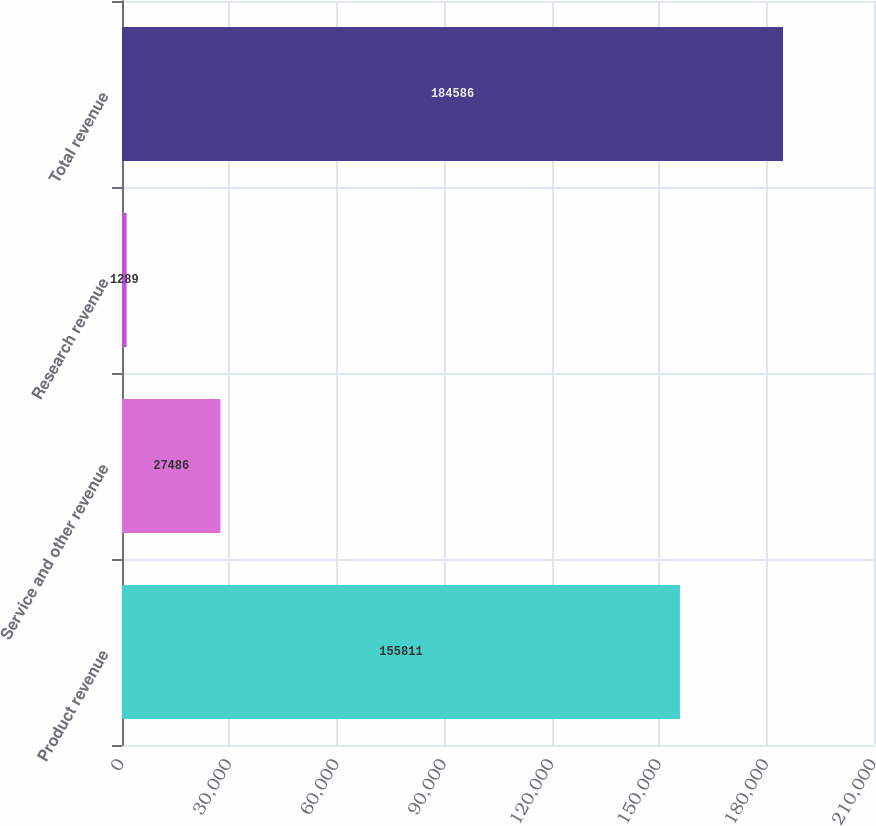<chart> <loc_0><loc_0><loc_500><loc_500><bar_chart><fcel>Product revenue<fcel>Service and other revenue<fcel>Research revenue<fcel>Total revenue<nl><fcel>155811<fcel>27486<fcel>1289<fcel>184586<nl></chart> 